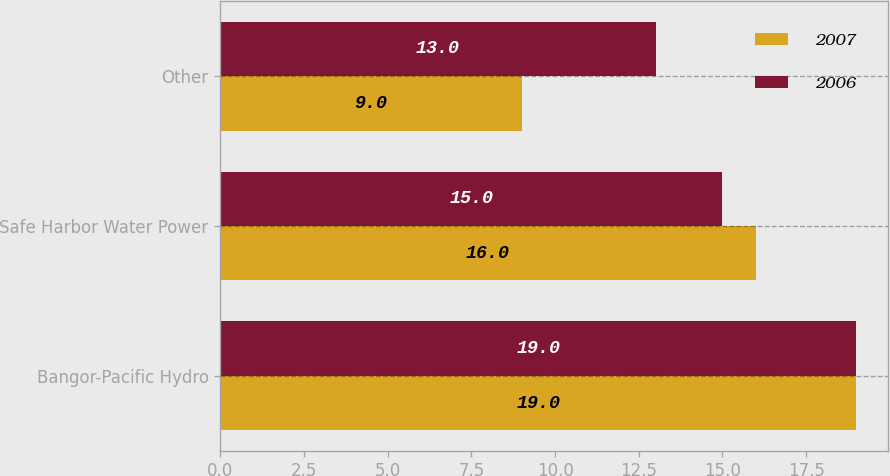Convert chart to OTSL. <chart><loc_0><loc_0><loc_500><loc_500><stacked_bar_chart><ecel><fcel>Bangor-Pacific Hydro<fcel>Safe Harbor Water Power<fcel>Other<nl><fcel>2007<fcel>19<fcel>16<fcel>9<nl><fcel>2006<fcel>19<fcel>15<fcel>13<nl></chart> 